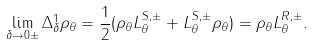Convert formula to latex. <formula><loc_0><loc_0><loc_500><loc_500>\lim _ { \delta \to 0 \pm } \Delta _ { \delta } ^ { 1 } \rho _ { \theta } = \frac { 1 } { 2 } ( \rho _ { \theta } L ^ { S , \pm } _ { \theta } + L ^ { S , \pm } _ { \theta } \rho _ { \theta } ) = \rho _ { \theta } L ^ { R , \pm } _ { \theta } .</formula> 